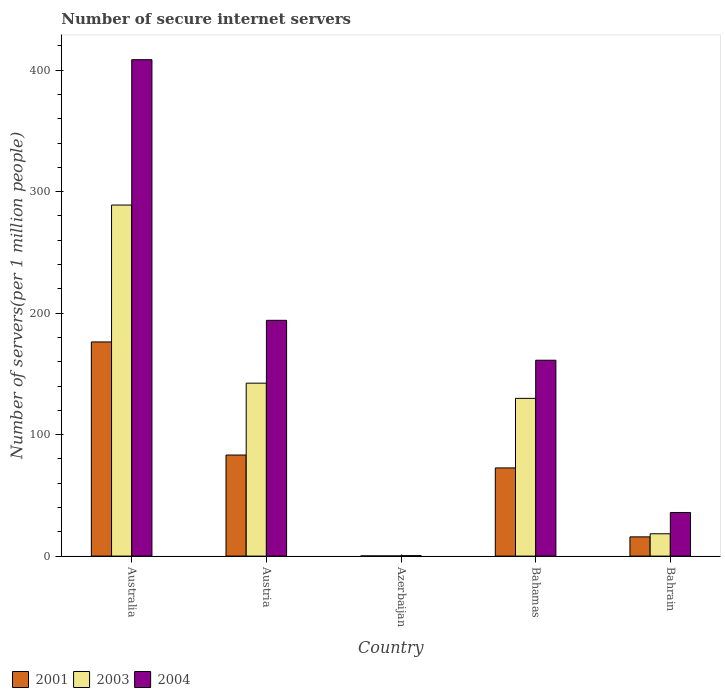How many bars are there on the 2nd tick from the right?
Make the answer very short. 3. In how many cases, is the number of bars for a given country not equal to the number of legend labels?
Ensure brevity in your answer.  0. What is the number of secure internet servers in 2003 in Australia?
Give a very brief answer. 288.96. Across all countries, what is the maximum number of secure internet servers in 2004?
Your answer should be very brief. 408.6. Across all countries, what is the minimum number of secure internet servers in 2001?
Offer a very short reply. 0.12. In which country was the number of secure internet servers in 2004 minimum?
Offer a very short reply. Azerbaijan. What is the total number of secure internet servers in 2004 in the graph?
Your answer should be very brief. 800.15. What is the difference between the number of secure internet servers in 2001 in Australia and that in Austria?
Make the answer very short. 93.09. What is the difference between the number of secure internet servers in 2001 in Bahamas and the number of secure internet servers in 2004 in Bahrain?
Provide a short and direct response. 36.68. What is the average number of secure internet servers in 2003 per country?
Provide a short and direct response. 115.93. What is the difference between the number of secure internet servers of/in 2004 and number of secure internet servers of/in 2003 in Austria?
Provide a short and direct response. 51.74. What is the ratio of the number of secure internet servers in 2001 in Bahamas to that in Bahrain?
Offer a very short reply. 4.58. Is the number of secure internet servers in 2003 in Azerbaijan less than that in Bahamas?
Your answer should be very brief. Yes. Is the difference between the number of secure internet servers in 2004 in Azerbaijan and Bahrain greater than the difference between the number of secure internet servers in 2003 in Azerbaijan and Bahrain?
Provide a short and direct response. No. What is the difference between the highest and the second highest number of secure internet servers in 2001?
Give a very brief answer. 103.7. What is the difference between the highest and the lowest number of secure internet servers in 2004?
Ensure brevity in your answer.  408.24. What does the 1st bar from the left in Austria represents?
Your answer should be compact. 2001. How many bars are there?
Offer a terse response. 15. Are all the bars in the graph horizontal?
Keep it short and to the point. No. How many countries are there in the graph?
Provide a short and direct response. 5. What is the difference between two consecutive major ticks on the Y-axis?
Your response must be concise. 100. Are the values on the major ticks of Y-axis written in scientific E-notation?
Your answer should be compact. No. Does the graph contain any zero values?
Keep it short and to the point. No. Does the graph contain grids?
Offer a very short reply. No. Where does the legend appear in the graph?
Your response must be concise. Bottom left. How many legend labels are there?
Your answer should be very brief. 3. How are the legend labels stacked?
Provide a succinct answer. Horizontal. What is the title of the graph?
Offer a terse response. Number of secure internet servers. Does "1981" appear as one of the legend labels in the graph?
Your answer should be very brief. No. What is the label or title of the Y-axis?
Your answer should be compact. Number of servers(per 1 million people). What is the Number of servers(per 1 million people) in 2001 in Australia?
Offer a terse response. 176.27. What is the Number of servers(per 1 million people) of 2003 in Australia?
Offer a very short reply. 288.96. What is the Number of servers(per 1 million people) of 2004 in Australia?
Your response must be concise. 408.6. What is the Number of servers(per 1 million people) of 2001 in Austria?
Provide a succinct answer. 83.19. What is the Number of servers(per 1 million people) of 2003 in Austria?
Give a very brief answer. 142.34. What is the Number of servers(per 1 million people) in 2004 in Austria?
Offer a terse response. 194.08. What is the Number of servers(per 1 million people) in 2001 in Azerbaijan?
Your answer should be compact. 0.12. What is the Number of servers(per 1 million people) in 2003 in Azerbaijan?
Ensure brevity in your answer.  0.12. What is the Number of servers(per 1 million people) in 2004 in Azerbaijan?
Your answer should be very brief. 0.36. What is the Number of servers(per 1 million people) of 2001 in Bahamas?
Ensure brevity in your answer.  72.57. What is the Number of servers(per 1 million people) in 2003 in Bahamas?
Provide a succinct answer. 129.85. What is the Number of servers(per 1 million people) in 2004 in Bahamas?
Provide a short and direct response. 161.22. What is the Number of servers(per 1 million people) of 2001 in Bahrain?
Your answer should be very brief. 15.83. What is the Number of servers(per 1 million people) in 2003 in Bahrain?
Offer a terse response. 18.38. What is the Number of servers(per 1 million people) in 2004 in Bahrain?
Make the answer very short. 35.89. Across all countries, what is the maximum Number of servers(per 1 million people) of 2001?
Your response must be concise. 176.27. Across all countries, what is the maximum Number of servers(per 1 million people) of 2003?
Provide a short and direct response. 288.96. Across all countries, what is the maximum Number of servers(per 1 million people) in 2004?
Ensure brevity in your answer.  408.6. Across all countries, what is the minimum Number of servers(per 1 million people) of 2001?
Make the answer very short. 0.12. Across all countries, what is the minimum Number of servers(per 1 million people) of 2003?
Make the answer very short. 0.12. Across all countries, what is the minimum Number of servers(per 1 million people) in 2004?
Your answer should be compact. 0.36. What is the total Number of servers(per 1 million people) of 2001 in the graph?
Make the answer very short. 347.99. What is the total Number of servers(per 1 million people) of 2003 in the graph?
Provide a succinct answer. 579.65. What is the total Number of servers(per 1 million people) of 2004 in the graph?
Your answer should be compact. 800.15. What is the difference between the Number of servers(per 1 million people) in 2001 in Australia and that in Austria?
Make the answer very short. 93.09. What is the difference between the Number of servers(per 1 million people) of 2003 in Australia and that in Austria?
Your answer should be compact. 146.62. What is the difference between the Number of servers(per 1 million people) in 2004 in Australia and that in Austria?
Make the answer very short. 214.52. What is the difference between the Number of servers(per 1 million people) in 2001 in Australia and that in Azerbaijan?
Your response must be concise. 176.15. What is the difference between the Number of servers(per 1 million people) in 2003 in Australia and that in Azerbaijan?
Give a very brief answer. 288.84. What is the difference between the Number of servers(per 1 million people) of 2004 in Australia and that in Azerbaijan?
Keep it short and to the point. 408.24. What is the difference between the Number of servers(per 1 million people) of 2001 in Australia and that in Bahamas?
Your answer should be very brief. 103.7. What is the difference between the Number of servers(per 1 million people) of 2003 in Australia and that in Bahamas?
Your response must be concise. 159.11. What is the difference between the Number of servers(per 1 million people) in 2004 in Australia and that in Bahamas?
Keep it short and to the point. 247.38. What is the difference between the Number of servers(per 1 million people) of 2001 in Australia and that in Bahrain?
Provide a short and direct response. 160.44. What is the difference between the Number of servers(per 1 million people) in 2003 in Australia and that in Bahrain?
Make the answer very short. 270.58. What is the difference between the Number of servers(per 1 million people) in 2004 in Australia and that in Bahrain?
Make the answer very short. 372.71. What is the difference between the Number of servers(per 1 million people) in 2001 in Austria and that in Azerbaijan?
Your answer should be very brief. 83.06. What is the difference between the Number of servers(per 1 million people) in 2003 in Austria and that in Azerbaijan?
Give a very brief answer. 142.22. What is the difference between the Number of servers(per 1 million people) of 2004 in Austria and that in Azerbaijan?
Offer a very short reply. 193.72. What is the difference between the Number of servers(per 1 million people) in 2001 in Austria and that in Bahamas?
Offer a terse response. 10.61. What is the difference between the Number of servers(per 1 million people) of 2003 in Austria and that in Bahamas?
Keep it short and to the point. 12.49. What is the difference between the Number of servers(per 1 million people) of 2004 in Austria and that in Bahamas?
Provide a succinct answer. 32.86. What is the difference between the Number of servers(per 1 million people) in 2001 in Austria and that in Bahrain?
Ensure brevity in your answer.  67.36. What is the difference between the Number of servers(per 1 million people) in 2003 in Austria and that in Bahrain?
Ensure brevity in your answer.  123.96. What is the difference between the Number of servers(per 1 million people) in 2004 in Austria and that in Bahrain?
Keep it short and to the point. 158.19. What is the difference between the Number of servers(per 1 million people) in 2001 in Azerbaijan and that in Bahamas?
Give a very brief answer. -72.45. What is the difference between the Number of servers(per 1 million people) of 2003 in Azerbaijan and that in Bahamas?
Keep it short and to the point. -129.73. What is the difference between the Number of servers(per 1 million people) in 2004 in Azerbaijan and that in Bahamas?
Offer a terse response. -160.86. What is the difference between the Number of servers(per 1 million people) of 2001 in Azerbaijan and that in Bahrain?
Provide a short and direct response. -15.71. What is the difference between the Number of servers(per 1 million people) of 2003 in Azerbaijan and that in Bahrain?
Offer a very short reply. -18.26. What is the difference between the Number of servers(per 1 million people) in 2004 in Azerbaijan and that in Bahrain?
Your answer should be very brief. -35.53. What is the difference between the Number of servers(per 1 million people) of 2001 in Bahamas and that in Bahrain?
Offer a very short reply. 56.74. What is the difference between the Number of servers(per 1 million people) of 2003 in Bahamas and that in Bahrain?
Offer a very short reply. 111.46. What is the difference between the Number of servers(per 1 million people) of 2004 in Bahamas and that in Bahrain?
Your answer should be very brief. 125.33. What is the difference between the Number of servers(per 1 million people) of 2001 in Australia and the Number of servers(per 1 million people) of 2003 in Austria?
Your answer should be compact. 33.93. What is the difference between the Number of servers(per 1 million people) of 2001 in Australia and the Number of servers(per 1 million people) of 2004 in Austria?
Your response must be concise. -17.8. What is the difference between the Number of servers(per 1 million people) of 2003 in Australia and the Number of servers(per 1 million people) of 2004 in Austria?
Make the answer very short. 94.88. What is the difference between the Number of servers(per 1 million people) in 2001 in Australia and the Number of servers(per 1 million people) in 2003 in Azerbaijan?
Make the answer very short. 176.15. What is the difference between the Number of servers(per 1 million people) in 2001 in Australia and the Number of servers(per 1 million people) in 2004 in Azerbaijan?
Offer a very short reply. 175.91. What is the difference between the Number of servers(per 1 million people) of 2003 in Australia and the Number of servers(per 1 million people) of 2004 in Azerbaijan?
Ensure brevity in your answer.  288.6. What is the difference between the Number of servers(per 1 million people) of 2001 in Australia and the Number of servers(per 1 million people) of 2003 in Bahamas?
Offer a terse response. 46.43. What is the difference between the Number of servers(per 1 million people) in 2001 in Australia and the Number of servers(per 1 million people) in 2004 in Bahamas?
Offer a terse response. 15.05. What is the difference between the Number of servers(per 1 million people) in 2003 in Australia and the Number of servers(per 1 million people) in 2004 in Bahamas?
Give a very brief answer. 127.74. What is the difference between the Number of servers(per 1 million people) in 2001 in Australia and the Number of servers(per 1 million people) in 2003 in Bahrain?
Your answer should be very brief. 157.89. What is the difference between the Number of servers(per 1 million people) of 2001 in Australia and the Number of servers(per 1 million people) of 2004 in Bahrain?
Keep it short and to the point. 140.38. What is the difference between the Number of servers(per 1 million people) in 2003 in Australia and the Number of servers(per 1 million people) in 2004 in Bahrain?
Make the answer very short. 253.07. What is the difference between the Number of servers(per 1 million people) in 2001 in Austria and the Number of servers(per 1 million people) in 2003 in Azerbaijan?
Make the answer very short. 83.06. What is the difference between the Number of servers(per 1 million people) of 2001 in Austria and the Number of servers(per 1 million people) of 2004 in Azerbaijan?
Your answer should be compact. 82.82. What is the difference between the Number of servers(per 1 million people) in 2003 in Austria and the Number of servers(per 1 million people) in 2004 in Azerbaijan?
Offer a terse response. 141.98. What is the difference between the Number of servers(per 1 million people) in 2001 in Austria and the Number of servers(per 1 million people) in 2003 in Bahamas?
Make the answer very short. -46.66. What is the difference between the Number of servers(per 1 million people) of 2001 in Austria and the Number of servers(per 1 million people) of 2004 in Bahamas?
Give a very brief answer. -78.04. What is the difference between the Number of servers(per 1 million people) in 2003 in Austria and the Number of servers(per 1 million people) in 2004 in Bahamas?
Give a very brief answer. -18.88. What is the difference between the Number of servers(per 1 million people) in 2001 in Austria and the Number of servers(per 1 million people) in 2003 in Bahrain?
Offer a very short reply. 64.8. What is the difference between the Number of servers(per 1 million people) of 2001 in Austria and the Number of servers(per 1 million people) of 2004 in Bahrain?
Provide a short and direct response. 47.29. What is the difference between the Number of servers(per 1 million people) of 2003 in Austria and the Number of servers(per 1 million people) of 2004 in Bahrain?
Offer a terse response. 106.45. What is the difference between the Number of servers(per 1 million people) of 2001 in Azerbaijan and the Number of servers(per 1 million people) of 2003 in Bahamas?
Offer a very short reply. -129.72. What is the difference between the Number of servers(per 1 million people) of 2001 in Azerbaijan and the Number of servers(per 1 million people) of 2004 in Bahamas?
Your response must be concise. -161.1. What is the difference between the Number of servers(per 1 million people) of 2003 in Azerbaijan and the Number of servers(per 1 million people) of 2004 in Bahamas?
Your answer should be compact. -161.1. What is the difference between the Number of servers(per 1 million people) of 2001 in Azerbaijan and the Number of servers(per 1 million people) of 2003 in Bahrain?
Ensure brevity in your answer.  -18.26. What is the difference between the Number of servers(per 1 million people) in 2001 in Azerbaijan and the Number of servers(per 1 million people) in 2004 in Bahrain?
Your answer should be compact. -35.77. What is the difference between the Number of servers(per 1 million people) of 2003 in Azerbaijan and the Number of servers(per 1 million people) of 2004 in Bahrain?
Your answer should be compact. -35.77. What is the difference between the Number of servers(per 1 million people) in 2001 in Bahamas and the Number of servers(per 1 million people) in 2003 in Bahrain?
Offer a very short reply. 54.19. What is the difference between the Number of servers(per 1 million people) of 2001 in Bahamas and the Number of servers(per 1 million people) of 2004 in Bahrain?
Give a very brief answer. 36.68. What is the difference between the Number of servers(per 1 million people) in 2003 in Bahamas and the Number of servers(per 1 million people) in 2004 in Bahrain?
Keep it short and to the point. 93.96. What is the average Number of servers(per 1 million people) of 2001 per country?
Offer a very short reply. 69.6. What is the average Number of servers(per 1 million people) in 2003 per country?
Give a very brief answer. 115.93. What is the average Number of servers(per 1 million people) of 2004 per country?
Your response must be concise. 160.03. What is the difference between the Number of servers(per 1 million people) in 2001 and Number of servers(per 1 million people) in 2003 in Australia?
Offer a very short reply. -112.69. What is the difference between the Number of servers(per 1 million people) of 2001 and Number of servers(per 1 million people) of 2004 in Australia?
Ensure brevity in your answer.  -232.32. What is the difference between the Number of servers(per 1 million people) of 2003 and Number of servers(per 1 million people) of 2004 in Australia?
Offer a very short reply. -119.64. What is the difference between the Number of servers(per 1 million people) of 2001 and Number of servers(per 1 million people) of 2003 in Austria?
Your response must be concise. -59.15. What is the difference between the Number of servers(per 1 million people) in 2001 and Number of servers(per 1 million people) in 2004 in Austria?
Your answer should be very brief. -110.89. What is the difference between the Number of servers(per 1 million people) of 2003 and Number of servers(per 1 million people) of 2004 in Austria?
Ensure brevity in your answer.  -51.74. What is the difference between the Number of servers(per 1 million people) of 2001 and Number of servers(per 1 million people) of 2003 in Azerbaijan?
Provide a succinct answer. 0. What is the difference between the Number of servers(per 1 million people) in 2001 and Number of servers(per 1 million people) in 2004 in Azerbaijan?
Provide a short and direct response. -0.24. What is the difference between the Number of servers(per 1 million people) in 2003 and Number of servers(per 1 million people) in 2004 in Azerbaijan?
Offer a terse response. -0.24. What is the difference between the Number of servers(per 1 million people) of 2001 and Number of servers(per 1 million people) of 2003 in Bahamas?
Keep it short and to the point. -57.27. What is the difference between the Number of servers(per 1 million people) in 2001 and Number of servers(per 1 million people) in 2004 in Bahamas?
Give a very brief answer. -88.65. What is the difference between the Number of servers(per 1 million people) of 2003 and Number of servers(per 1 million people) of 2004 in Bahamas?
Give a very brief answer. -31.37. What is the difference between the Number of servers(per 1 million people) of 2001 and Number of servers(per 1 million people) of 2003 in Bahrain?
Keep it short and to the point. -2.55. What is the difference between the Number of servers(per 1 million people) of 2001 and Number of servers(per 1 million people) of 2004 in Bahrain?
Provide a short and direct response. -20.06. What is the difference between the Number of servers(per 1 million people) in 2003 and Number of servers(per 1 million people) in 2004 in Bahrain?
Make the answer very short. -17.51. What is the ratio of the Number of servers(per 1 million people) of 2001 in Australia to that in Austria?
Ensure brevity in your answer.  2.12. What is the ratio of the Number of servers(per 1 million people) in 2003 in Australia to that in Austria?
Offer a very short reply. 2.03. What is the ratio of the Number of servers(per 1 million people) in 2004 in Australia to that in Austria?
Keep it short and to the point. 2.11. What is the ratio of the Number of servers(per 1 million people) in 2001 in Australia to that in Azerbaijan?
Give a very brief answer. 1429.79. What is the ratio of the Number of servers(per 1 million people) of 2003 in Australia to that in Azerbaijan?
Make the answer very short. 2379.34. What is the ratio of the Number of servers(per 1 million people) in 2004 in Australia to that in Azerbaijan?
Make the answer very short. 1131.34. What is the ratio of the Number of servers(per 1 million people) of 2001 in Australia to that in Bahamas?
Your response must be concise. 2.43. What is the ratio of the Number of servers(per 1 million people) of 2003 in Australia to that in Bahamas?
Your answer should be very brief. 2.23. What is the ratio of the Number of servers(per 1 million people) in 2004 in Australia to that in Bahamas?
Your answer should be very brief. 2.53. What is the ratio of the Number of servers(per 1 million people) of 2001 in Australia to that in Bahrain?
Your answer should be compact. 11.14. What is the ratio of the Number of servers(per 1 million people) of 2003 in Australia to that in Bahrain?
Offer a terse response. 15.72. What is the ratio of the Number of servers(per 1 million people) of 2004 in Australia to that in Bahrain?
Provide a short and direct response. 11.38. What is the ratio of the Number of servers(per 1 million people) of 2001 in Austria to that in Azerbaijan?
Your response must be concise. 674.73. What is the ratio of the Number of servers(per 1 million people) of 2003 in Austria to that in Azerbaijan?
Your answer should be compact. 1172.04. What is the ratio of the Number of servers(per 1 million people) in 2004 in Austria to that in Azerbaijan?
Make the answer very short. 537.37. What is the ratio of the Number of servers(per 1 million people) of 2001 in Austria to that in Bahamas?
Offer a terse response. 1.15. What is the ratio of the Number of servers(per 1 million people) in 2003 in Austria to that in Bahamas?
Provide a succinct answer. 1.1. What is the ratio of the Number of servers(per 1 million people) in 2004 in Austria to that in Bahamas?
Your answer should be very brief. 1.2. What is the ratio of the Number of servers(per 1 million people) of 2001 in Austria to that in Bahrain?
Make the answer very short. 5.25. What is the ratio of the Number of servers(per 1 million people) in 2003 in Austria to that in Bahrain?
Ensure brevity in your answer.  7.74. What is the ratio of the Number of servers(per 1 million people) of 2004 in Austria to that in Bahrain?
Provide a succinct answer. 5.41. What is the ratio of the Number of servers(per 1 million people) in 2001 in Azerbaijan to that in Bahamas?
Your response must be concise. 0. What is the ratio of the Number of servers(per 1 million people) in 2003 in Azerbaijan to that in Bahamas?
Give a very brief answer. 0. What is the ratio of the Number of servers(per 1 million people) of 2004 in Azerbaijan to that in Bahamas?
Make the answer very short. 0. What is the ratio of the Number of servers(per 1 million people) in 2001 in Azerbaijan to that in Bahrain?
Provide a short and direct response. 0.01. What is the ratio of the Number of servers(per 1 million people) of 2003 in Azerbaijan to that in Bahrain?
Offer a terse response. 0.01. What is the ratio of the Number of servers(per 1 million people) of 2004 in Azerbaijan to that in Bahrain?
Provide a short and direct response. 0.01. What is the ratio of the Number of servers(per 1 million people) of 2001 in Bahamas to that in Bahrain?
Provide a succinct answer. 4.58. What is the ratio of the Number of servers(per 1 million people) in 2003 in Bahamas to that in Bahrain?
Your response must be concise. 7.06. What is the ratio of the Number of servers(per 1 million people) in 2004 in Bahamas to that in Bahrain?
Your answer should be very brief. 4.49. What is the difference between the highest and the second highest Number of servers(per 1 million people) of 2001?
Your answer should be very brief. 93.09. What is the difference between the highest and the second highest Number of servers(per 1 million people) of 2003?
Make the answer very short. 146.62. What is the difference between the highest and the second highest Number of servers(per 1 million people) of 2004?
Your answer should be very brief. 214.52. What is the difference between the highest and the lowest Number of servers(per 1 million people) in 2001?
Ensure brevity in your answer.  176.15. What is the difference between the highest and the lowest Number of servers(per 1 million people) of 2003?
Provide a succinct answer. 288.84. What is the difference between the highest and the lowest Number of servers(per 1 million people) in 2004?
Keep it short and to the point. 408.24. 